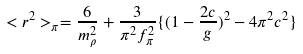<formula> <loc_0><loc_0><loc_500><loc_500>< r ^ { 2 } > _ { \pi } = { \frac { 6 } { m _ { \rho } ^ { 2 } } } + { \frac { 3 } { \pi ^ { 2 } f _ { \pi } ^ { 2 } } } \{ ( 1 - { \frac { 2 c } { g } } ) ^ { 2 } - 4 \pi ^ { 2 } c ^ { 2 } \}</formula> 